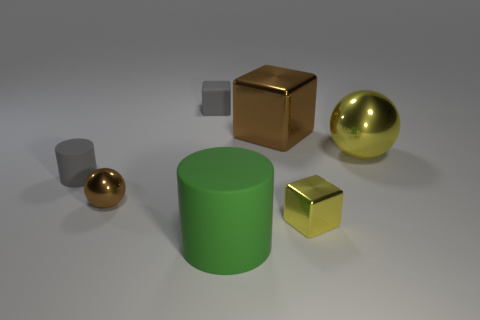Add 1 big green rubber cylinders. How many objects exist? 8 Subtract all cubes. How many objects are left? 4 Subtract 0 blue blocks. How many objects are left? 7 Subtract all small spheres. Subtract all big green rubber cylinders. How many objects are left? 5 Add 3 small brown objects. How many small brown objects are left? 4 Add 2 small cylinders. How many small cylinders exist? 3 